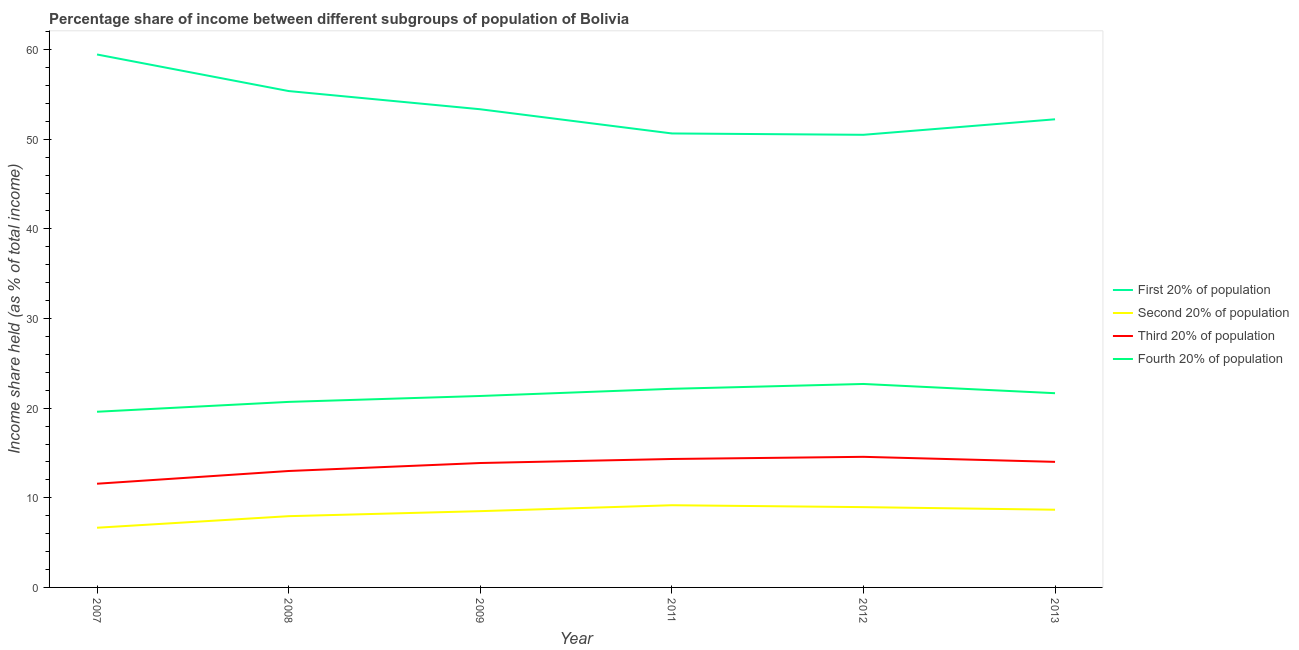How many different coloured lines are there?
Your answer should be very brief. 4. Is the number of lines equal to the number of legend labels?
Keep it short and to the point. Yes. What is the share of the income held by third 20% of the population in 2012?
Offer a very short reply. 14.57. Across all years, what is the maximum share of the income held by fourth 20% of the population?
Ensure brevity in your answer.  22.7. Across all years, what is the minimum share of the income held by first 20% of the population?
Offer a terse response. 50.5. In which year was the share of the income held by third 20% of the population maximum?
Make the answer very short. 2012. What is the total share of the income held by first 20% of the population in the graph?
Give a very brief answer. 321.57. What is the difference between the share of the income held by fourth 20% of the population in 2007 and that in 2008?
Offer a very short reply. -1.1. What is the difference between the share of the income held by first 20% of the population in 2011 and the share of the income held by third 20% of the population in 2012?
Ensure brevity in your answer.  36.08. What is the average share of the income held by fourth 20% of the population per year?
Make the answer very short. 21.36. In the year 2013, what is the difference between the share of the income held by first 20% of the population and share of the income held by second 20% of the population?
Your answer should be very brief. 43.56. In how many years, is the share of the income held by second 20% of the population greater than 20 %?
Give a very brief answer. 0. What is the ratio of the share of the income held by fourth 20% of the population in 2008 to that in 2011?
Give a very brief answer. 0.93. Is the share of the income held by second 20% of the population in 2009 less than that in 2013?
Your answer should be very brief. Yes. What is the difference between the highest and the second highest share of the income held by fourth 20% of the population?
Offer a terse response. 0.54. What is the difference between the highest and the lowest share of the income held by second 20% of the population?
Keep it short and to the point. 2.51. In how many years, is the share of the income held by fourth 20% of the population greater than the average share of the income held by fourth 20% of the population taken over all years?
Offer a very short reply. 3. Is the share of the income held by first 20% of the population strictly greater than the share of the income held by third 20% of the population over the years?
Your answer should be very brief. Yes. How many years are there in the graph?
Offer a terse response. 6. What is the difference between two consecutive major ticks on the Y-axis?
Make the answer very short. 10. Are the values on the major ticks of Y-axis written in scientific E-notation?
Ensure brevity in your answer.  No. Does the graph contain any zero values?
Offer a very short reply. No. Where does the legend appear in the graph?
Keep it short and to the point. Center right. How many legend labels are there?
Provide a succinct answer. 4. What is the title of the graph?
Provide a short and direct response. Percentage share of income between different subgroups of population of Bolivia. What is the label or title of the Y-axis?
Your response must be concise. Income share held (as % of total income). What is the Income share held (as % of total income) in First 20% of population in 2007?
Offer a terse response. 59.46. What is the Income share held (as % of total income) of Second 20% of population in 2007?
Your response must be concise. 6.66. What is the Income share held (as % of total income) in Third 20% of population in 2007?
Ensure brevity in your answer.  11.57. What is the Income share held (as % of total income) of Fourth 20% of population in 2007?
Ensure brevity in your answer.  19.6. What is the Income share held (as % of total income) in First 20% of population in 2008?
Your answer should be compact. 55.38. What is the Income share held (as % of total income) in Second 20% of population in 2008?
Provide a short and direct response. 7.95. What is the Income share held (as % of total income) in Third 20% of population in 2008?
Provide a short and direct response. 12.99. What is the Income share held (as % of total income) of Fourth 20% of population in 2008?
Your answer should be compact. 20.7. What is the Income share held (as % of total income) in First 20% of population in 2009?
Ensure brevity in your answer.  53.35. What is the Income share held (as % of total income) of Second 20% of population in 2009?
Your answer should be compact. 8.51. What is the Income share held (as % of total income) in Third 20% of population in 2009?
Your response must be concise. 13.88. What is the Income share held (as % of total income) of Fourth 20% of population in 2009?
Your answer should be compact. 21.36. What is the Income share held (as % of total income) of First 20% of population in 2011?
Offer a terse response. 50.65. What is the Income share held (as % of total income) of Second 20% of population in 2011?
Offer a very short reply. 9.17. What is the Income share held (as % of total income) of Third 20% of population in 2011?
Your answer should be compact. 14.33. What is the Income share held (as % of total income) in Fourth 20% of population in 2011?
Keep it short and to the point. 22.16. What is the Income share held (as % of total income) in First 20% of population in 2012?
Your answer should be compact. 50.5. What is the Income share held (as % of total income) of Second 20% of population in 2012?
Your answer should be very brief. 8.96. What is the Income share held (as % of total income) of Third 20% of population in 2012?
Your answer should be compact. 14.57. What is the Income share held (as % of total income) in Fourth 20% of population in 2012?
Give a very brief answer. 22.7. What is the Income share held (as % of total income) in First 20% of population in 2013?
Ensure brevity in your answer.  52.23. What is the Income share held (as % of total income) in Second 20% of population in 2013?
Offer a terse response. 8.67. What is the Income share held (as % of total income) in Third 20% of population in 2013?
Your response must be concise. 14.01. What is the Income share held (as % of total income) of Fourth 20% of population in 2013?
Ensure brevity in your answer.  21.67. Across all years, what is the maximum Income share held (as % of total income) of First 20% of population?
Your answer should be very brief. 59.46. Across all years, what is the maximum Income share held (as % of total income) in Second 20% of population?
Provide a short and direct response. 9.17. Across all years, what is the maximum Income share held (as % of total income) in Third 20% of population?
Give a very brief answer. 14.57. Across all years, what is the maximum Income share held (as % of total income) of Fourth 20% of population?
Your answer should be very brief. 22.7. Across all years, what is the minimum Income share held (as % of total income) in First 20% of population?
Make the answer very short. 50.5. Across all years, what is the minimum Income share held (as % of total income) of Second 20% of population?
Offer a very short reply. 6.66. Across all years, what is the minimum Income share held (as % of total income) in Third 20% of population?
Offer a terse response. 11.57. Across all years, what is the minimum Income share held (as % of total income) of Fourth 20% of population?
Keep it short and to the point. 19.6. What is the total Income share held (as % of total income) in First 20% of population in the graph?
Your response must be concise. 321.57. What is the total Income share held (as % of total income) of Second 20% of population in the graph?
Keep it short and to the point. 49.92. What is the total Income share held (as % of total income) of Third 20% of population in the graph?
Ensure brevity in your answer.  81.35. What is the total Income share held (as % of total income) of Fourth 20% of population in the graph?
Provide a short and direct response. 128.19. What is the difference between the Income share held (as % of total income) in First 20% of population in 2007 and that in 2008?
Your answer should be very brief. 4.08. What is the difference between the Income share held (as % of total income) in Second 20% of population in 2007 and that in 2008?
Provide a succinct answer. -1.29. What is the difference between the Income share held (as % of total income) of Third 20% of population in 2007 and that in 2008?
Your answer should be compact. -1.42. What is the difference between the Income share held (as % of total income) in First 20% of population in 2007 and that in 2009?
Your answer should be compact. 6.11. What is the difference between the Income share held (as % of total income) in Second 20% of population in 2007 and that in 2009?
Keep it short and to the point. -1.85. What is the difference between the Income share held (as % of total income) in Third 20% of population in 2007 and that in 2009?
Provide a succinct answer. -2.31. What is the difference between the Income share held (as % of total income) in Fourth 20% of population in 2007 and that in 2009?
Keep it short and to the point. -1.76. What is the difference between the Income share held (as % of total income) of First 20% of population in 2007 and that in 2011?
Your response must be concise. 8.81. What is the difference between the Income share held (as % of total income) of Second 20% of population in 2007 and that in 2011?
Provide a short and direct response. -2.51. What is the difference between the Income share held (as % of total income) in Third 20% of population in 2007 and that in 2011?
Keep it short and to the point. -2.76. What is the difference between the Income share held (as % of total income) in Fourth 20% of population in 2007 and that in 2011?
Your answer should be very brief. -2.56. What is the difference between the Income share held (as % of total income) of First 20% of population in 2007 and that in 2012?
Your answer should be compact. 8.96. What is the difference between the Income share held (as % of total income) of Second 20% of population in 2007 and that in 2012?
Keep it short and to the point. -2.3. What is the difference between the Income share held (as % of total income) of Third 20% of population in 2007 and that in 2012?
Offer a terse response. -3. What is the difference between the Income share held (as % of total income) of First 20% of population in 2007 and that in 2013?
Make the answer very short. 7.23. What is the difference between the Income share held (as % of total income) in Second 20% of population in 2007 and that in 2013?
Offer a very short reply. -2.01. What is the difference between the Income share held (as % of total income) of Third 20% of population in 2007 and that in 2013?
Offer a terse response. -2.44. What is the difference between the Income share held (as % of total income) in Fourth 20% of population in 2007 and that in 2013?
Give a very brief answer. -2.07. What is the difference between the Income share held (as % of total income) in First 20% of population in 2008 and that in 2009?
Provide a short and direct response. 2.03. What is the difference between the Income share held (as % of total income) in Second 20% of population in 2008 and that in 2009?
Provide a succinct answer. -0.56. What is the difference between the Income share held (as % of total income) in Third 20% of population in 2008 and that in 2009?
Offer a very short reply. -0.89. What is the difference between the Income share held (as % of total income) in Fourth 20% of population in 2008 and that in 2009?
Your response must be concise. -0.66. What is the difference between the Income share held (as % of total income) of First 20% of population in 2008 and that in 2011?
Your response must be concise. 4.73. What is the difference between the Income share held (as % of total income) of Second 20% of population in 2008 and that in 2011?
Provide a short and direct response. -1.22. What is the difference between the Income share held (as % of total income) in Third 20% of population in 2008 and that in 2011?
Your answer should be very brief. -1.34. What is the difference between the Income share held (as % of total income) in Fourth 20% of population in 2008 and that in 2011?
Offer a very short reply. -1.46. What is the difference between the Income share held (as % of total income) of First 20% of population in 2008 and that in 2012?
Your answer should be very brief. 4.88. What is the difference between the Income share held (as % of total income) in Second 20% of population in 2008 and that in 2012?
Your answer should be compact. -1.01. What is the difference between the Income share held (as % of total income) in Third 20% of population in 2008 and that in 2012?
Provide a succinct answer. -1.58. What is the difference between the Income share held (as % of total income) of First 20% of population in 2008 and that in 2013?
Your answer should be very brief. 3.15. What is the difference between the Income share held (as % of total income) in Second 20% of population in 2008 and that in 2013?
Your response must be concise. -0.72. What is the difference between the Income share held (as % of total income) of Third 20% of population in 2008 and that in 2013?
Offer a very short reply. -1.02. What is the difference between the Income share held (as % of total income) of Fourth 20% of population in 2008 and that in 2013?
Offer a terse response. -0.97. What is the difference between the Income share held (as % of total income) of First 20% of population in 2009 and that in 2011?
Offer a terse response. 2.7. What is the difference between the Income share held (as % of total income) of Second 20% of population in 2009 and that in 2011?
Provide a short and direct response. -0.66. What is the difference between the Income share held (as % of total income) in Third 20% of population in 2009 and that in 2011?
Provide a short and direct response. -0.45. What is the difference between the Income share held (as % of total income) of Fourth 20% of population in 2009 and that in 2011?
Offer a terse response. -0.8. What is the difference between the Income share held (as % of total income) in First 20% of population in 2009 and that in 2012?
Ensure brevity in your answer.  2.85. What is the difference between the Income share held (as % of total income) of Second 20% of population in 2009 and that in 2012?
Keep it short and to the point. -0.45. What is the difference between the Income share held (as % of total income) in Third 20% of population in 2009 and that in 2012?
Offer a very short reply. -0.69. What is the difference between the Income share held (as % of total income) of Fourth 20% of population in 2009 and that in 2012?
Offer a very short reply. -1.34. What is the difference between the Income share held (as % of total income) in First 20% of population in 2009 and that in 2013?
Make the answer very short. 1.12. What is the difference between the Income share held (as % of total income) in Second 20% of population in 2009 and that in 2013?
Ensure brevity in your answer.  -0.16. What is the difference between the Income share held (as % of total income) of Third 20% of population in 2009 and that in 2013?
Keep it short and to the point. -0.13. What is the difference between the Income share held (as % of total income) of Fourth 20% of population in 2009 and that in 2013?
Ensure brevity in your answer.  -0.31. What is the difference between the Income share held (as % of total income) of Second 20% of population in 2011 and that in 2012?
Provide a succinct answer. 0.21. What is the difference between the Income share held (as % of total income) in Third 20% of population in 2011 and that in 2012?
Make the answer very short. -0.24. What is the difference between the Income share held (as % of total income) in Fourth 20% of population in 2011 and that in 2012?
Your answer should be compact. -0.54. What is the difference between the Income share held (as % of total income) in First 20% of population in 2011 and that in 2013?
Your answer should be compact. -1.58. What is the difference between the Income share held (as % of total income) of Third 20% of population in 2011 and that in 2013?
Provide a succinct answer. 0.32. What is the difference between the Income share held (as % of total income) in Fourth 20% of population in 2011 and that in 2013?
Ensure brevity in your answer.  0.49. What is the difference between the Income share held (as % of total income) of First 20% of population in 2012 and that in 2013?
Your answer should be very brief. -1.73. What is the difference between the Income share held (as % of total income) of Second 20% of population in 2012 and that in 2013?
Your response must be concise. 0.29. What is the difference between the Income share held (as % of total income) of Third 20% of population in 2012 and that in 2013?
Provide a short and direct response. 0.56. What is the difference between the Income share held (as % of total income) in First 20% of population in 2007 and the Income share held (as % of total income) in Second 20% of population in 2008?
Your answer should be compact. 51.51. What is the difference between the Income share held (as % of total income) of First 20% of population in 2007 and the Income share held (as % of total income) of Third 20% of population in 2008?
Offer a terse response. 46.47. What is the difference between the Income share held (as % of total income) in First 20% of population in 2007 and the Income share held (as % of total income) in Fourth 20% of population in 2008?
Offer a terse response. 38.76. What is the difference between the Income share held (as % of total income) in Second 20% of population in 2007 and the Income share held (as % of total income) in Third 20% of population in 2008?
Ensure brevity in your answer.  -6.33. What is the difference between the Income share held (as % of total income) in Second 20% of population in 2007 and the Income share held (as % of total income) in Fourth 20% of population in 2008?
Offer a very short reply. -14.04. What is the difference between the Income share held (as % of total income) of Third 20% of population in 2007 and the Income share held (as % of total income) of Fourth 20% of population in 2008?
Your answer should be compact. -9.13. What is the difference between the Income share held (as % of total income) of First 20% of population in 2007 and the Income share held (as % of total income) of Second 20% of population in 2009?
Your answer should be very brief. 50.95. What is the difference between the Income share held (as % of total income) of First 20% of population in 2007 and the Income share held (as % of total income) of Third 20% of population in 2009?
Give a very brief answer. 45.58. What is the difference between the Income share held (as % of total income) in First 20% of population in 2007 and the Income share held (as % of total income) in Fourth 20% of population in 2009?
Offer a terse response. 38.1. What is the difference between the Income share held (as % of total income) of Second 20% of population in 2007 and the Income share held (as % of total income) of Third 20% of population in 2009?
Your answer should be very brief. -7.22. What is the difference between the Income share held (as % of total income) in Second 20% of population in 2007 and the Income share held (as % of total income) in Fourth 20% of population in 2009?
Your answer should be very brief. -14.7. What is the difference between the Income share held (as % of total income) of Third 20% of population in 2007 and the Income share held (as % of total income) of Fourth 20% of population in 2009?
Provide a succinct answer. -9.79. What is the difference between the Income share held (as % of total income) of First 20% of population in 2007 and the Income share held (as % of total income) of Second 20% of population in 2011?
Keep it short and to the point. 50.29. What is the difference between the Income share held (as % of total income) of First 20% of population in 2007 and the Income share held (as % of total income) of Third 20% of population in 2011?
Keep it short and to the point. 45.13. What is the difference between the Income share held (as % of total income) in First 20% of population in 2007 and the Income share held (as % of total income) in Fourth 20% of population in 2011?
Give a very brief answer. 37.3. What is the difference between the Income share held (as % of total income) of Second 20% of population in 2007 and the Income share held (as % of total income) of Third 20% of population in 2011?
Give a very brief answer. -7.67. What is the difference between the Income share held (as % of total income) in Second 20% of population in 2007 and the Income share held (as % of total income) in Fourth 20% of population in 2011?
Offer a terse response. -15.5. What is the difference between the Income share held (as % of total income) in Third 20% of population in 2007 and the Income share held (as % of total income) in Fourth 20% of population in 2011?
Give a very brief answer. -10.59. What is the difference between the Income share held (as % of total income) of First 20% of population in 2007 and the Income share held (as % of total income) of Second 20% of population in 2012?
Offer a terse response. 50.5. What is the difference between the Income share held (as % of total income) in First 20% of population in 2007 and the Income share held (as % of total income) in Third 20% of population in 2012?
Keep it short and to the point. 44.89. What is the difference between the Income share held (as % of total income) in First 20% of population in 2007 and the Income share held (as % of total income) in Fourth 20% of population in 2012?
Ensure brevity in your answer.  36.76. What is the difference between the Income share held (as % of total income) of Second 20% of population in 2007 and the Income share held (as % of total income) of Third 20% of population in 2012?
Ensure brevity in your answer.  -7.91. What is the difference between the Income share held (as % of total income) in Second 20% of population in 2007 and the Income share held (as % of total income) in Fourth 20% of population in 2012?
Give a very brief answer. -16.04. What is the difference between the Income share held (as % of total income) of Third 20% of population in 2007 and the Income share held (as % of total income) of Fourth 20% of population in 2012?
Your answer should be compact. -11.13. What is the difference between the Income share held (as % of total income) in First 20% of population in 2007 and the Income share held (as % of total income) in Second 20% of population in 2013?
Your answer should be very brief. 50.79. What is the difference between the Income share held (as % of total income) of First 20% of population in 2007 and the Income share held (as % of total income) of Third 20% of population in 2013?
Your answer should be very brief. 45.45. What is the difference between the Income share held (as % of total income) in First 20% of population in 2007 and the Income share held (as % of total income) in Fourth 20% of population in 2013?
Your response must be concise. 37.79. What is the difference between the Income share held (as % of total income) in Second 20% of population in 2007 and the Income share held (as % of total income) in Third 20% of population in 2013?
Ensure brevity in your answer.  -7.35. What is the difference between the Income share held (as % of total income) in Second 20% of population in 2007 and the Income share held (as % of total income) in Fourth 20% of population in 2013?
Your response must be concise. -15.01. What is the difference between the Income share held (as % of total income) in Third 20% of population in 2007 and the Income share held (as % of total income) in Fourth 20% of population in 2013?
Offer a very short reply. -10.1. What is the difference between the Income share held (as % of total income) of First 20% of population in 2008 and the Income share held (as % of total income) of Second 20% of population in 2009?
Your answer should be compact. 46.87. What is the difference between the Income share held (as % of total income) of First 20% of population in 2008 and the Income share held (as % of total income) of Third 20% of population in 2009?
Keep it short and to the point. 41.5. What is the difference between the Income share held (as % of total income) of First 20% of population in 2008 and the Income share held (as % of total income) of Fourth 20% of population in 2009?
Offer a very short reply. 34.02. What is the difference between the Income share held (as % of total income) of Second 20% of population in 2008 and the Income share held (as % of total income) of Third 20% of population in 2009?
Your response must be concise. -5.93. What is the difference between the Income share held (as % of total income) in Second 20% of population in 2008 and the Income share held (as % of total income) in Fourth 20% of population in 2009?
Ensure brevity in your answer.  -13.41. What is the difference between the Income share held (as % of total income) in Third 20% of population in 2008 and the Income share held (as % of total income) in Fourth 20% of population in 2009?
Your answer should be compact. -8.37. What is the difference between the Income share held (as % of total income) in First 20% of population in 2008 and the Income share held (as % of total income) in Second 20% of population in 2011?
Your response must be concise. 46.21. What is the difference between the Income share held (as % of total income) of First 20% of population in 2008 and the Income share held (as % of total income) of Third 20% of population in 2011?
Your answer should be compact. 41.05. What is the difference between the Income share held (as % of total income) in First 20% of population in 2008 and the Income share held (as % of total income) in Fourth 20% of population in 2011?
Give a very brief answer. 33.22. What is the difference between the Income share held (as % of total income) in Second 20% of population in 2008 and the Income share held (as % of total income) in Third 20% of population in 2011?
Give a very brief answer. -6.38. What is the difference between the Income share held (as % of total income) of Second 20% of population in 2008 and the Income share held (as % of total income) of Fourth 20% of population in 2011?
Keep it short and to the point. -14.21. What is the difference between the Income share held (as % of total income) in Third 20% of population in 2008 and the Income share held (as % of total income) in Fourth 20% of population in 2011?
Your answer should be very brief. -9.17. What is the difference between the Income share held (as % of total income) in First 20% of population in 2008 and the Income share held (as % of total income) in Second 20% of population in 2012?
Provide a short and direct response. 46.42. What is the difference between the Income share held (as % of total income) in First 20% of population in 2008 and the Income share held (as % of total income) in Third 20% of population in 2012?
Make the answer very short. 40.81. What is the difference between the Income share held (as % of total income) in First 20% of population in 2008 and the Income share held (as % of total income) in Fourth 20% of population in 2012?
Ensure brevity in your answer.  32.68. What is the difference between the Income share held (as % of total income) in Second 20% of population in 2008 and the Income share held (as % of total income) in Third 20% of population in 2012?
Offer a very short reply. -6.62. What is the difference between the Income share held (as % of total income) in Second 20% of population in 2008 and the Income share held (as % of total income) in Fourth 20% of population in 2012?
Offer a very short reply. -14.75. What is the difference between the Income share held (as % of total income) in Third 20% of population in 2008 and the Income share held (as % of total income) in Fourth 20% of population in 2012?
Offer a very short reply. -9.71. What is the difference between the Income share held (as % of total income) of First 20% of population in 2008 and the Income share held (as % of total income) of Second 20% of population in 2013?
Keep it short and to the point. 46.71. What is the difference between the Income share held (as % of total income) of First 20% of population in 2008 and the Income share held (as % of total income) of Third 20% of population in 2013?
Give a very brief answer. 41.37. What is the difference between the Income share held (as % of total income) of First 20% of population in 2008 and the Income share held (as % of total income) of Fourth 20% of population in 2013?
Offer a terse response. 33.71. What is the difference between the Income share held (as % of total income) in Second 20% of population in 2008 and the Income share held (as % of total income) in Third 20% of population in 2013?
Offer a very short reply. -6.06. What is the difference between the Income share held (as % of total income) in Second 20% of population in 2008 and the Income share held (as % of total income) in Fourth 20% of population in 2013?
Your answer should be very brief. -13.72. What is the difference between the Income share held (as % of total income) of Third 20% of population in 2008 and the Income share held (as % of total income) of Fourth 20% of population in 2013?
Your answer should be very brief. -8.68. What is the difference between the Income share held (as % of total income) of First 20% of population in 2009 and the Income share held (as % of total income) of Second 20% of population in 2011?
Give a very brief answer. 44.18. What is the difference between the Income share held (as % of total income) in First 20% of population in 2009 and the Income share held (as % of total income) in Third 20% of population in 2011?
Give a very brief answer. 39.02. What is the difference between the Income share held (as % of total income) in First 20% of population in 2009 and the Income share held (as % of total income) in Fourth 20% of population in 2011?
Make the answer very short. 31.19. What is the difference between the Income share held (as % of total income) in Second 20% of population in 2009 and the Income share held (as % of total income) in Third 20% of population in 2011?
Your answer should be very brief. -5.82. What is the difference between the Income share held (as % of total income) of Second 20% of population in 2009 and the Income share held (as % of total income) of Fourth 20% of population in 2011?
Your answer should be compact. -13.65. What is the difference between the Income share held (as % of total income) of Third 20% of population in 2009 and the Income share held (as % of total income) of Fourth 20% of population in 2011?
Keep it short and to the point. -8.28. What is the difference between the Income share held (as % of total income) of First 20% of population in 2009 and the Income share held (as % of total income) of Second 20% of population in 2012?
Your answer should be very brief. 44.39. What is the difference between the Income share held (as % of total income) in First 20% of population in 2009 and the Income share held (as % of total income) in Third 20% of population in 2012?
Your answer should be very brief. 38.78. What is the difference between the Income share held (as % of total income) in First 20% of population in 2009 and the Income share held (as % of total income) in Fourth 20% of population in 2012?
Offer a terse response. 30.65. What is the difference between the Income share held (as % of total income) in Second 20% of population in 2009 and the Income share held (as % of total income) in Third 20% of population in 2012?
Give a very brief answer. -6.06. What is the difference between the Income share held (as % of total income) of Second 20% of population in 2009 and the Income share held (as % of total income) of Fourth 20% of population in 2012?
Offer a terse response. -14.19. What is the difference between the Income share held (as % of total income) of Third 20% of population in 2009 and the Income share held (as % of total income) of Fourth 20% of population in 2012?
Give a very brief answer. -8.82. What is the difference between the Income share held (as % of total income) of First 20% of population in 2009 and the Income share held (as % of total income) of Second 20% of population in 2013?
Your response must be concise. 44.68. What is the difference between the Income share held (as % of total income) of First 20% of population in 2009 and the Income share held (as % of total income) of Third 20% of population in 2013?
Your answer should be compact. 39.34. What is the difference between the Income share held (as % of total income) of First 20% of population in 2009 and the Income share held (as % of total income) of Fourth 20% of population in 2013?
Your answer should be compact. 31.68. What is the difference between the Income share held (as % of total income) in Second 20% of population in 2009 and the Income share held (as % of total income) in Fourth 20% of population in 2013?
Provide a succinct answer. -13.16. What is the difference between the Income share held (as % of total income) of Third 20% of population in 2009 and the Income share held (as % of total income) of Fourth 20% of population in 2013?
Make the answer very short. -7.79. What is the difference between the Income share held (as % of total income) in First 20% of population in 2011 and the Income share held (as % of total income) in Second 20% of population in 2012?
Offer a very short reply. 41.69. What is the difference between the Income share held (as % of total income) in First 20% of population in 2011 and the Income share held (as % of total income) in Third 20% of population in 2012?
Your answer should be very brief. 36.08. What is the difference between the Income share held (as % of total income) in First 20% of population in 2011 and the Income share held (as % of total income) in Fourth 20% of population in 2012?
Make the answer very short. 27.95. What is the difference between the Income share held (as % of total income) of Second 20% of population in 2011 and the Income share held (as % of total income) of Third 20% of population in 2012?
Offer a terse response. -5.4. What is the difference between the Income share held (as % of total income) of Second 20% of population in 2011 and the Income share held (as % of total income) of Fourth 20% of population in 2012?
Offer a terse response. -13.53. What is the difference between the Income share held (as % of total income) in Third 20% of population in 2011 and the Income share held (as % of total income) in Fourth 20% of population in 2012?
Your response must be concise. -8.37. What is the difference between the Income share held (as % of total income) in First 20% of population in 2011 and the Income share held (as % of total income) in Second 20% of population in 2013?
Keep it short and to the point. 41.98. What is the difference between the Income share held (as % of total income) in First 20% of population in 2011 and the Income share held (as % of total income) in Third 20% of population in 2013?
Offer a very short reply. 36.64. What is the difference between the Income share held (as % of total income) of First 20% of population in 2011 and the Income share held (as % of total income) of Fourth 20% of population in 2013?
Your answer should be very brief. 28.98. What is the difference between the Income share held (as % of total income) of Second 20% of population in 2011 and the Income share held (as % of total income) of Third 20% of population in 2013?
Your response must be concise. -4.84. What is the difference between the Income share held (as % of total income) of Second 20% of population in 2011 and the Income share held (as % of total income) of Fourth 20% of population in 2013?
Ensure brevity in your answer.  -12.5. What is the difference between the Income share held (as % of total income) of Third 20% of population in 2011 and the Income share held (as % of total income) of Fourth 20% of population in 2013?
Your answer should be very brief. -7.34. What is the difference between the Income share held (as % of total income) in First 20% of population in 2012 and the Income share held (as % of total income) in Second 20% of population in 2013?
Your answer should be very brief. 41.83. What is the difference between the Income share held (as % of total income) of First 20% of population in 2012 and the Income share held (as % of total income) of Third 20% of population in 2013?
Provide a succinct answer. 36.49. What is the difference between the Income share held (as % of total income) of First 20% of population in 2012 and the Income share held (as % of total income) of Fourth 20% of population in 2013?
Offer a very short reply. 28.83. What is the difference between the Income share held (as % of total income) in Second 20% of population in 2012 and the Income share held (as % of total income) in Third 20% of population in 2013?
Your response must be concise. -5.05. What is the difference between the Income share held (as % of total income) in Second 20% of population in 2012 and the Income share held (as % of total income) in Fourth 20% of population in 2013?
Provide a short and direct response. -12.71. What is the difference between the Income share held (as % of total income) in Third 20% of population in 2012 and the Income share held (as % of total income) in Fourth 20% of population in 2013?
Give a very brief answer. -7.1. What is the average Income share held (as % of total income) in First 20% of population per year?
Offer a terse response. 53.59. What is the average Income share held (as % of total income) in Second 20% of population per year?
Make the answer very short. 8.32. What is the average Income share held (as % of total income) in Third 20% of population per year?
Offer a terse response. 13.56. What is the average Income share held (as % of total income) in Fourth 20% of population per year?
Make the answer very short. 21.36. In the year 2007, what is the difference between the Income share held (as % of total income) in First 20% of population and Income share held (as % of total income) in Second 20% of population?
Offer a very short reply. 52.8. In the year 2007, what is the difference between the Income share held (as % of total income) in First 20% of population and Income share held (as % of total income) in Third 20% of population?
Ensure brevity in your answer.  47.89. In the year 2007, what is the difference between the Income share held (as % of total income) in First 20% of population and Income share held (as % of total income) in Fourth 20% of population?
Give a very brief answer. 39.86. In the year 2007, what is the difference between the Income share held (as % of total income) in Second 20% of population and Income share held (as % of total income) in Third 20% of population?
Your answer should be compact. -4.91. In the year 2007, what is the difference between the Income share held (as % of total income) in Second 20% of population and Income share held (as % of total income) in Fourth 20% of population?
Provide a succinct answer. -12.94. In the year 2007, what is the difference between the Income share held (as % of total income) of Third 20% of population and Income share held (as % of total income) of Fourth 20% of population?
Offer a terse response. -8.03. In the year 2008, what is the difference between the Income share held (as % of total income) of First 20% of population and Income share held (as % of total income) of Second 20% of population?
Your answer should be compact. 47.43. In the year 2008, what is the difference between the Income share held (as % of total income) of First 20% of population and Income share held (as % of total income) of Third 20% of population?
Give a very brief answer. 42.39. In the year 2008, what is the difference between the Income share held (as % of total income) of First 20% of population and Income share held (as % of total income) of Fourth 20% of population?
Give a very brief answer. 34.68. In the year 2008, what is the difference between the Income share held (as % of total income) of Second 20% of population and Income share held (as % of total income) of Third 20% of population?
Keep it short and to the point. -5.04. In the year 2008, what is the difference between the Income share held (as % of total income) in Second 20% of population and Income share held (as % of total income) in Fourth 20% of population?
Your answer should be compact. -12.75. In the year 2008, what is the difference between the Income share held (as % of total income) of Third 20% of population and Income share held (as % of total income) of Fourth 20% of population?
Provide a succinct answer. -7.71. In the year 2009, what is the difference between the Income share held (as % of total income) in First 20% of population and Income share held (as % of total income) in Second 20% of population?
Ensure brevity in your answer.  44.84. In the year 2009, what is the difference between the Income share held (as % of total income) of First 20% of population and Income share held (as % of total income) of Third 20% of population?
Keep it short and to the point. 39.47. In the year 2009, what is the difference between the Income share held (as % of total income) in First 20% of population and Income share held (as % of total income) in Fourth 20% of population?
Provide a succinct answer. 31.99. In the year 2009, what is the difference between the Income share held (as % of total income) in Second 20% of population and Income share held (as % of total income) in Third 20% of population?
Your answer should be compact. -5.37. In the year 2009, what is the difference between the Income share held (as % of total income) of Second 20% of population and Income share held (as % of total income) of Fourth 20% of population?
Your answer should be compact. -12.85. In the year 2009, what is the difference between the Income share held (as % of total income) of Third 20% of population and Income share held (as % of total income) of Fourth 20% of population?
Offer a terse response. -7.48. In the year 2011, what is the difference between the Income share held (as % of total income) in First 20% of population and Income share held (as % of total income) in Second 20% of population?
Make the answer very short. 41.48. In the year 2011, what is the difference between the Income share held (as % of total income) in First 20% of population and Income share held (as % of total income) in Third 20% of population?
Your answer should be very brief. 36.32. In the year 2011, what is the difference between the Income share held (as % of total income) of First 20% of population and Income share held (as % of total income) of Fourth 20% of population?
Ensure brevity in your answer.  28.49. In the year 2011, what is the difference between the Income share held (as % of total income) in Second 20% of population and Income share held (as % of total income) in Third 20% of population?
Give a very brief answer. -5.16. In the year 2011, what is the difference between the Income share held (as % of total income) in Second 20% of population and Income share held (as % of total income) in Fourth 20% of population?
Offer a very short reply. -12.99. In the year 2011, what is the difference between the Income share held (as % of total income) in Third 20% of population and Income share held (as % of total income) in Fourth 20% of population?
Your response must be concise. -7.83. In the year 2012, what is the difference between the Income share held (as % of total income) in First 20% of population and Income share held (as % of total income) in Second 20% of population?
Your answer should be very brief. 41.54. In the year 2012, what is the difference between the Income share held (as % of total income) of First 20% of population and Income share held (as % of total income) of Third 20% of population?
Your answer should be compact. 35.93. In the year 2012, what is the difference between the Income share held (as % of total income) in First 20% of population and Income share held (as % of total income) in Fourth 20% of population?
Offer a very short reply. 27.8. In the year 2012, what is the difference between the Income share held (as % of total income) of Second 20% of population and Income share held (as % of total income) of Third 20% of population?
Offer a terse response. -5.61. In the year 2012, what is the difference between the Income share held (as % of total income) of Second 20% of population and Income share held (as % of total income) of Fourth 20% of population?
Your answer should be compact. -13.74. In the year 2012, what is the difference between the Income share held (as % of total income) of Third 20% of population and Income share held (as % of total income) of Fourth 20% of population?
Provide a short and direct response. -8.13. In the year 2013, what is the difference between the Income share held (as % of total income) of First 20% of population and Income share held (as % of total income) of Second 20% of population?
Offer a very short reply. 43.56. In the year 2013, what is the difference between the Income share held (as % of total income) in First 20% of population and Income share held (as % of total income) in Third 20% of population?
Make the answer very short. 38.22. In the year 2013, what is the difference between the Income share held (as % of total income) of First 20% of population and Income share held (as % of total income) of Fourth 20% of population?
Provide a succinct answer. 30.56. In the year 2013, what is the difference between the Income share held (as % of total income) in Second 20% of population and Income share held (as % of total income) in Third 20% of population?
Provide a succinct answer. -5.34. In the year 2013, what is the difference between the Income share held (as % of total income) of Second 20% of population and Income share held (as % of total income) of Fourth 20% of population?
Ensure brevity in your answer.  -13. In the year 2013, what is the difference between the Income share held (as % of total income) in Third 20% of population and Income share held (as % of total income) in Fourth 20% of population?
Your answer should be compact. -7.66. What is the ratio of the Income share held (as % of total income) of First 20% of population in 2007 to that in 2008?
Provide a short and direct response. 1.07. What is the ratio of the Income share held (as % of total income) in Second 20% of population in 2007 to that in 2008?
Ensure brevity in your answer.  0.84. What is the ratio of the Income share held (as % of total income) of Third 20% of population in 2007 to that in 2008?
Keep it short and to the point. 0.89. What is the ratio of the Income share held (as % of total income) of Fourth 20% of population in 2007 to that in 2008?
Give a very brief answer. 0.95. What is the ratio of the Income share held (as % of total income) of First 20% of population in 2007 to that in 2009?
Make the answer very short. 1.11. What is the ratio of the Income share held (as % of total income) of Second 20% of population in 2007 to that in 2009?
Provide a succinct answer. 0.78. What is the ratio of the Income share held (as % of total income) in Third 20% of population in 2007 to that in 2009?
Make the answer very short. 0.83. What is the ratio of the Income share held (as % of total income) in Fourth 20% of population in 2007 to that in 2009?
Provide a short and direct response. 0.92. What is the ratio of the Income share held (as % of total income) in First 20% of population in 2007 to that in 2011?
Your response must be concise. 1.17. What is the ratio of the Income share held (as % of total income) of Second 20% of population in 2007 to that in 2011?
Offer a very short reply. 0.73. What is the ratio of the Income share held (as % of total income) of Third 20% of population in 2007 to that in 2011?
Provide a short and direct response. 0.81. What is the ratio of the Income share held (as % of total income) in Fourth 20% of population in 2007 to that in 2011?
Your answer should be compact. 0.88. What is the ratio of the Income share held (as % of total income) in First 20% of population in 2007 to that in 2012?
Give a very brief answer. 1.18. What is the ratio of the Income share held (as % of total income) in Second 20% of population in 2007 to that in 2012?
Offer a terse response. 0.74. What is the ratio of the Income share held (as % of total income) in Third 20% of population in 2007 to that in 2012?
Offer a very short reply. 0.79. What is the ratio of the Income share held (as % of total income) in Fourth 20% of population in 2007 to that in 2012?
Provide a short and direct response. 0.86. What is the ratio of the Income share held (as % of total income) of First 20% of population in 2007 to that in 2013?
Your answer should be compact. 1.14. What is the ratio of the Income share held (as % of total income) of Second 20% of population in 2007 to that in 2013?
Keep it short and to the point. 0.77. What is the ratio of the Income share held (as % of total income) in Third 20% of population in 2007 to that in 2013?
Offer a very short reply. 0.83. What is the ratio of the Income share held (as % of total income) in Fourth 20% of population in 2007 to that in 2013?
Your answer should be compact. 0.9. What is the ratio of the Income share held (as % of total income) of First 20% of population in 2008 to that in 2009?
Offer a very short reply. 1.04. What is the ratio of the Income share held (as % of total income) in Second 20% of population in 2008 to that in 2009?
Your answer should be very brief. 0.93. What is the ratio of the Income share held (as % of total income) of Third 20% of population in 2008 to that in 2009?
Your response must be concise. 0.94. What is the ratio of the Income share held (as % of total income) of Fourth 20% of population in 2008 to that in 2009?
Your answer should be compact. 0.97. What is the ratio of the Income share held (as % of total income) of First 20% of population in 2008 to that in 2011?
Offer a terse response. 1.09. What is the ratio of the Income share held (as % of total income) of Second 20% of population in 2008 to that in 2011?
Offer a very short reply. 0.87. What is the ratio of the Income share held (as % of total income) in Third 20% of population in 2008 to that in 2011?
Your answer should be compact. 0.91. What is the ratio of the Income share held (as % of total income) in Fourth 20% of population in 2008 to that in 2011?
Your answer should be compact. 0.93. What is the ratio of the Income share held (as % of total income) in First 20% of population in 2008 to that in 2012?
Give a very brief answer. 1.1. What is the ratio of the Income share held (as % of total income) of Second 20% of population in 2008 to that in 2012?
Give a very brief answer. 0.89. What is the ratio of the Income share held (as % of total income) of Third 20% of population in 2008 to that in 2012?
Provide a short and direct response. 0.89. What is the ratio of the Income share held (as % of total income) of Fourth 20% of population in 2008 to that in 2012?
Offer a very short reply. 0.91. What is the ratio of the Income share held (as % of total income) in First 20% of population in 2008 to that in 2013?
Your answer should be compact. 1.06. What is the ratio of the Income share held (as % of total income) of Second 20% of population in 2008 to that in 2013?
Keep it short and to the point. 0.92. What is the ratio of the Income share held (as % of total income) of Third 20% of population in 2008 to that in 2013?
Offer a very short reply. 0.93. What is the ratio of the Income share held (as % of total income) in Fourth 20% of population in 2008 to that in 2013?
Offer a very short reply. 0.96. What is the ratio of the Income share held (as % of total income) of First 20% of population in 2009 to that in 2011?
Make the answer very short. 1.05. What is the ratio of the Income share held (as % of total income) in Second 20% of population in 2009 to that in 2011?
Your response must be concise. 0.93. What is the ratio of the Income share held (as % of total income) in Third 20% of population in 2009 to that in 2011?
Keep it short and to the point. 0.97. What is the ratio of the Income share held (as % of total income) in Fourth 20% of population in 2009 to that in 2011?
Make the answer very short. 0.96. What is the ratio of the Income share held (as % of total income) in First 20% of population in 2009 to that in 2012?
Provide a succinct answer. 1.06. What is the ratio of the Income share held (as % of total income) of Second 20% of population in 2009 to that in 2012?
Make the answer very short. 0.95. What is the ratio of the Income share held (as % of total income) in Third 20% of population in 2009 to that in 2012?
Your answer should be very brief. 0.95. What is the ratio of the Income share held (as % of total income) in Fourth 20% of population in 2009 to that in 2012?
Offer a very short reply. 0.94. What is the ratio of the Income share held (as % of total income) in First 20% of population in 2009 to that in 2013?
Provide a short and direct response. 1.02. What is the ratio of the Income share held (as % of total income) of Second 20% of population in 2009 to that in 2013?
Keep it short and to the point. 0.98. What is the ratio of the Income share held (as % of total income) of Fourth 20% of population in 2009 to that in 2013?
Make the answer very short. 0.99. What is the ratio of the Income share held (as % of total income) in First 20% of population in 2011 to that in 2012?
Offer a terse response. 1. What is the ratio of the Income share held (as % of total income) of Second 20% of population in 2011 to that in 2012?
Your answer should be very brief. 1.02. What is the ratio of the Income share held (as % of total income) of Third 20% of population in 2011 to that in 2012?
Provide a succinct answer. 0.98. What is the ratio of the Income share held (as % of total income) in Fourth 20% of population in 2011 to that in 2012?
Give a very brief answer. 0.98. What is the ratio of the Income share held (as % of total income) in First 20% of population in 2011 to that in 2013?
Give a very brief answer. 0.97. What is the ratio of the Income share held (as % of total income) of Second 20% of population in 2011 to that in 2013?
Offer a very short reply. 1.06. What is the ratio of the Income share held (as % of total income) in Third 20% of population in 2011 to that in 2013?
Your answer should be very brief. 1.02. What is the ratio of the Income share held (as % of total income) in Fourth 20% of population in 2011 to that in 2013?
Your answer should be very brief. 1.02. What is the ratio of the Income share held (as % of total income) of First 20% of population in 2012 to that in 2013?
Keep it short and to the point. 0.97. What is the ratio of the Income share held (as % of total income) in Second 20% of population in 2012 to that in 2013?
Make the answer very short. 1.03. What is the ratio of the Income share held (as % of total income) of Third 20% of population in 2012 to that in 2013?
Your answer should be very brief. 1.04. What is the ratio of the Income share held (as % of total income) of Fourth 20% of population in 2012 to that in 2013?
Make the answer very short. 1.05. What is the difference between the highest and the second highest Income share held (as % of total income) of First 20% of population?
Your answer should be very brief. 4.08. What is the difference between the highest and the second highest Income share held (as % of total income) of Second 20% of population?
Your response must be concise. 0.21. What is the difference between the highest and the second highest Income share held (as % of total income) of Third 20% of population?
Offer a very short reply. 0.24. What is the difference between the highest and the second highest Income share held (as % of total income) in Fourth 20% of population?
Offer a terse response. 0.54. What is the difference between the highest and the lowest Income share held (as % of total income) in First 20% of population?
Offer a very short reply. 8.96. What is the difference between the highest and the lowest Income share held (as % of total income) in Second 20% of population?
Keep it short and to the point. 2.51. 